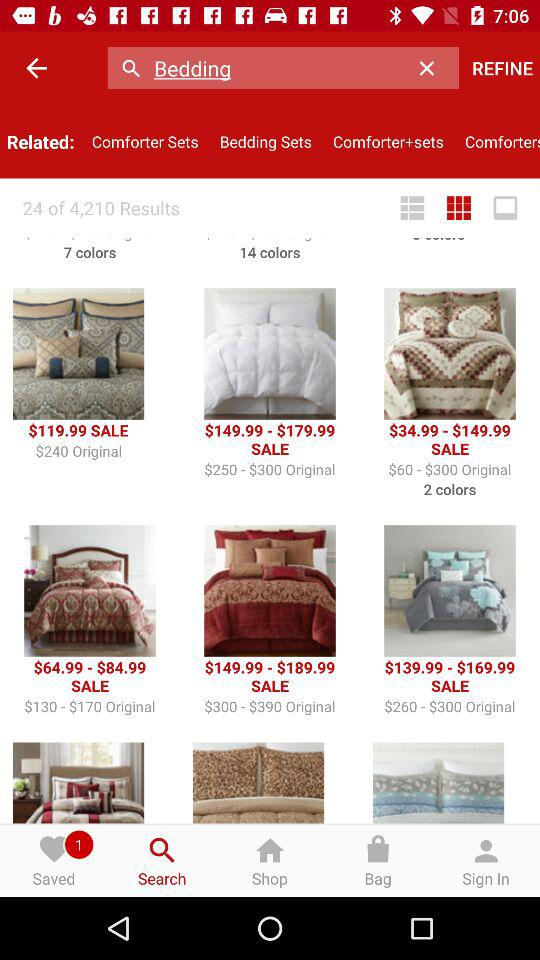How many colors are available for the first comforter?
Answer the question using a single word or phrase. 7 